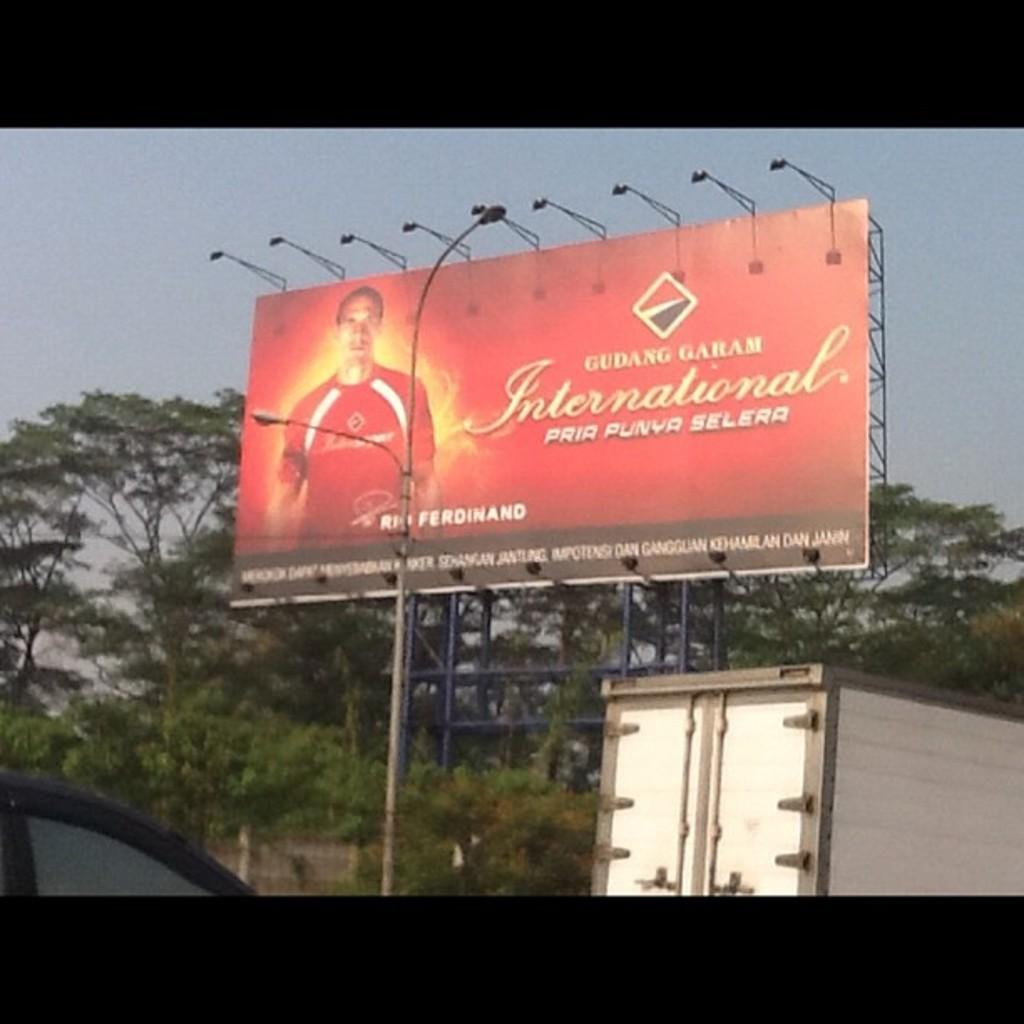<image>
Provide a brief description of the given image. A large red billboard says Gudang Garam is surrounded by trees and traffic. 